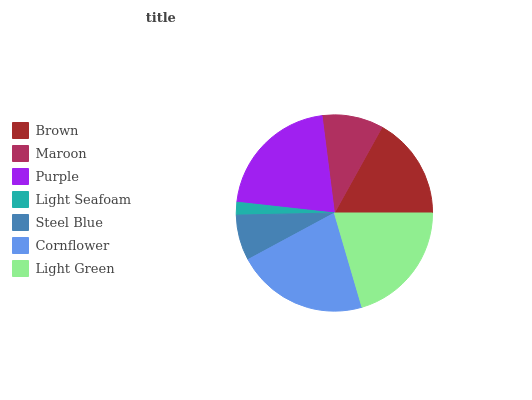Is Light Seafoam the minimum?
Answer yes or no. Yes. Is Cornflower the maximum?
Answer yes or no. Yes. Is Maroon the minimum?
Answer yes or no. No. Is Maroon the maximum?
Answer yes or no. No. Is Brown greater than Maroon?
Answer yes or no. Yes. Is Maroon less than Brown?
Answer yes or no. Yes. Is Maroon greater than Brown?
Answer yes or no. No. Is Brown less than Maroon?
Answer yes or no. No. Is Brown the high median?
Answer yes or no. Yes. Is Brown the low median?
Answer yes or no. Yes. Is Maroon the high median?
Answer yes or no. No. Is Steel Blue the low median?
Answer yes or no. No. 